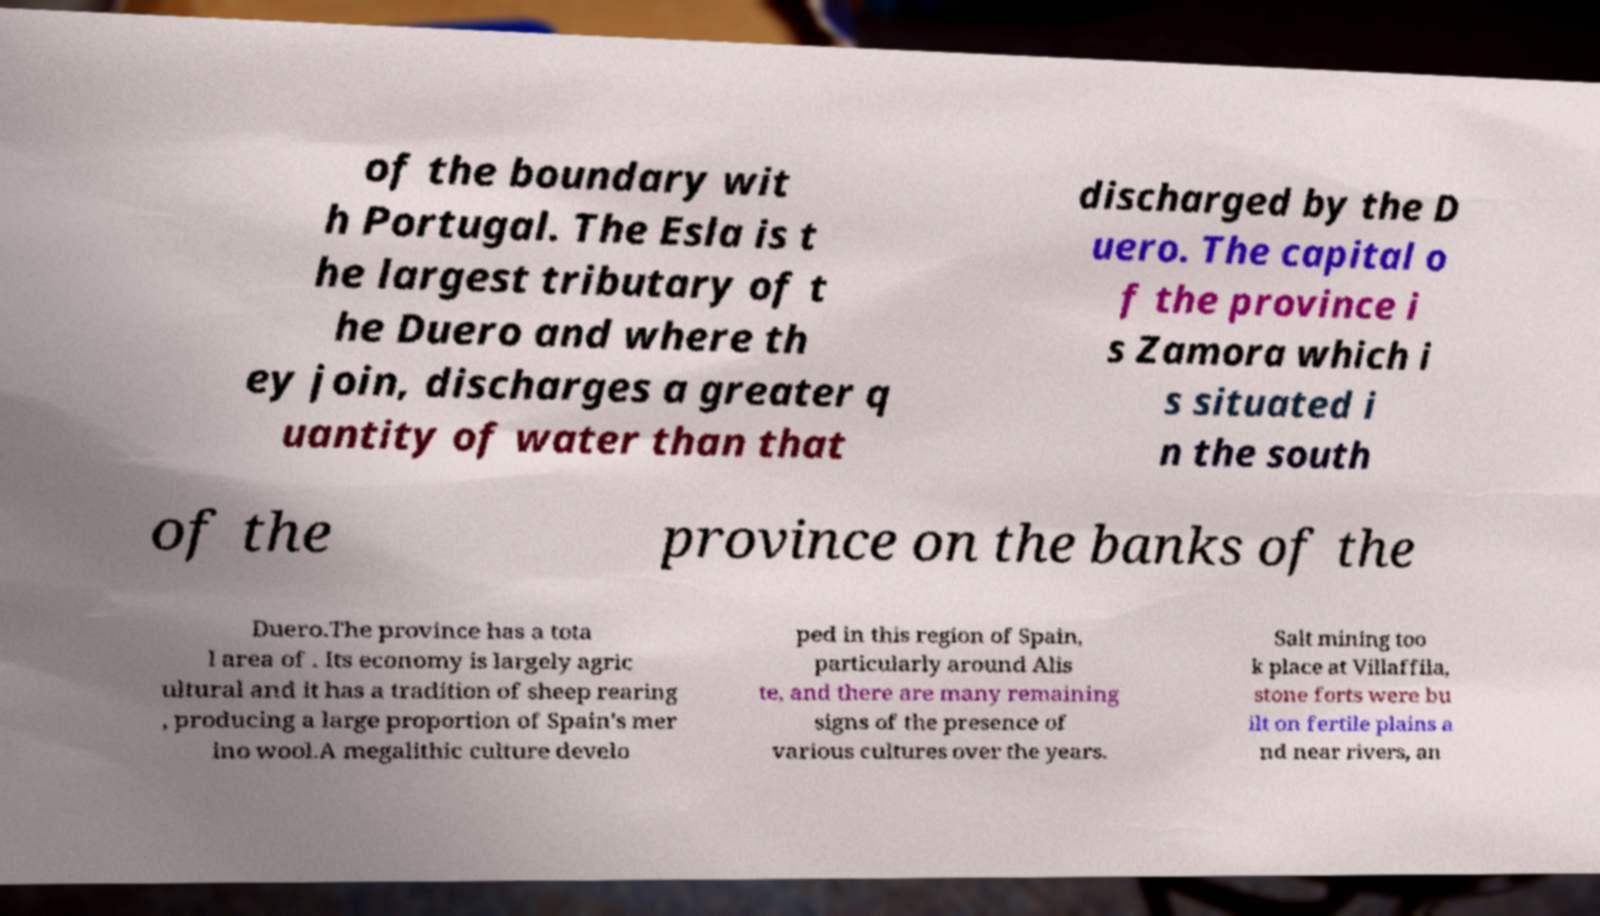Can you read and provide the text displayed in the image?This photo seems to have some interesting text. Can you extract and type it out for me? of the boundary wit h Portugal. The Esla is t he largest tributary of t he Duero and where th ey join, discharges a greater q uantity of water than that discharged by the D uero. The capital o f the province i s Zamora which i s situated i n the south of the province on the banks of the Duero.The province has a tota l area of . Its economy is largely agric ultural and it has a tradition of sheep rearing , producing a large proportion of Spain's mer ino wool.A megalithic culture develo ped in this region of Spain, particularly around Alis te, and there are many remaining signs of the presence of various cultures over the years. Salt mining too k place at Villaffila, stone forts were bu ilt on fertile plains a nd near rivers, an 